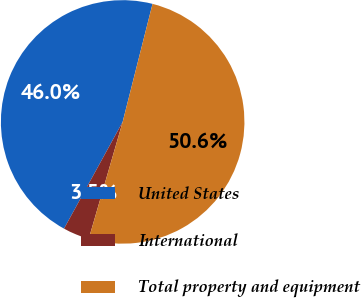Convert chart. <chart><loc_0><loc_0><loc_500><loc_500><pie_chart><fcel>United States<fcel>International<fcel>Total property and equipment<nl><fcel>45.95%<fcel>3.5%<fcel>50.55%<nl></chart> 